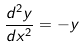Convert formula to latex. <formula><loc_0><loc_0><loc_500><loc_500>\frac { d ^ { 2 } y } { d x ^ { 2 } } = - y</formula> 